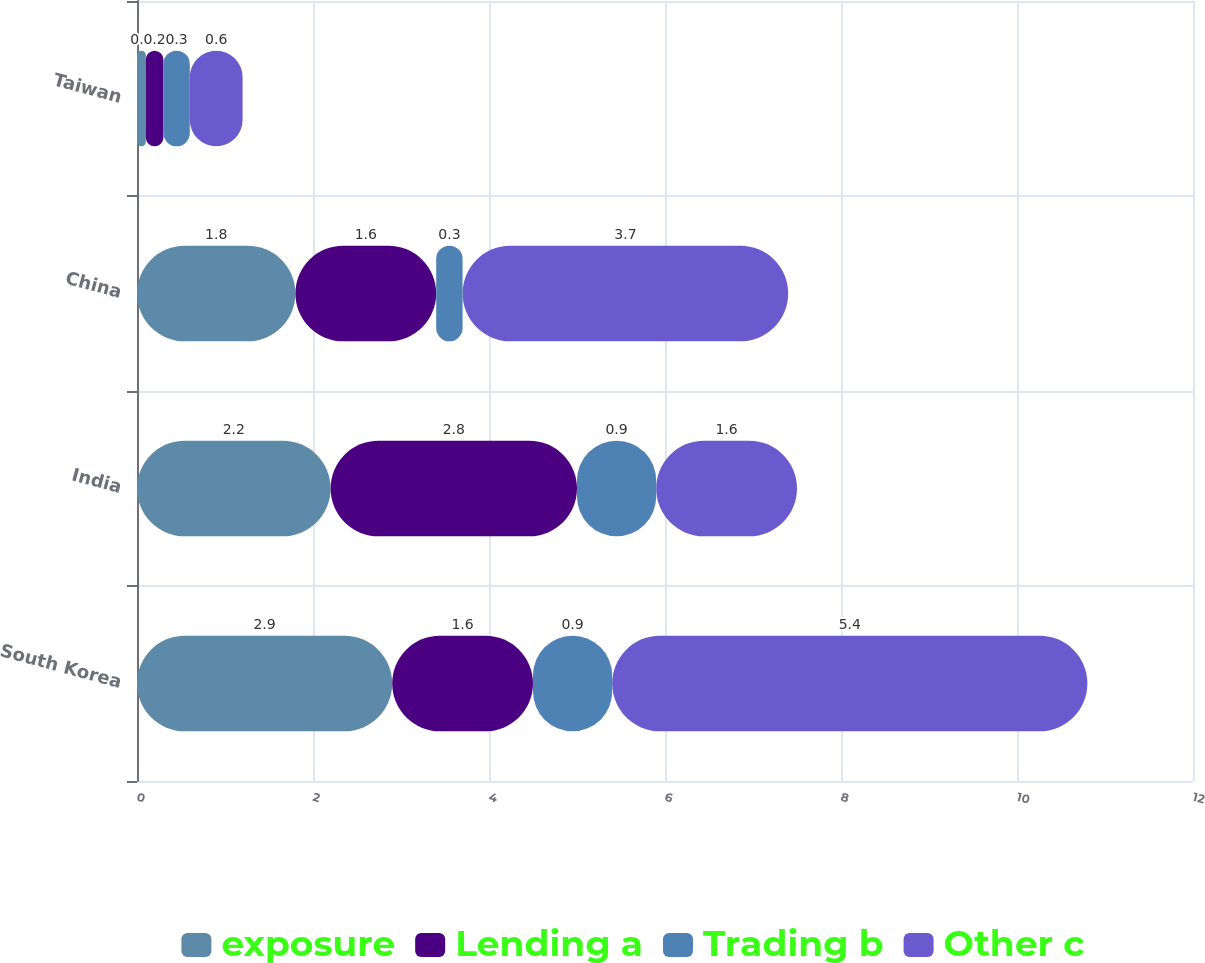<chart> <loc_0><loc_0><loc_500><loc_500><stacked_bar_chart><ecel><fcel>South Korea<fcel>India<fcel>China<fcel>Taiwan<nl><fcel>exposure<fcel>2.9<fcel>2.2<fcel>1.8<fcel>0.1<nl><fcel>Lending a<fcel>1.6<fcel>2.8<fcel>1.6<fcel>0.2<nl><fcel>Trading b<fcel>0.9<fcel>0.9<fcel>0.3<fcel>0.3<nl><fcel>Other c<fcel>5.4<fcel>1.6<fcel>3.7<fcel>0.6<nl></chart> 